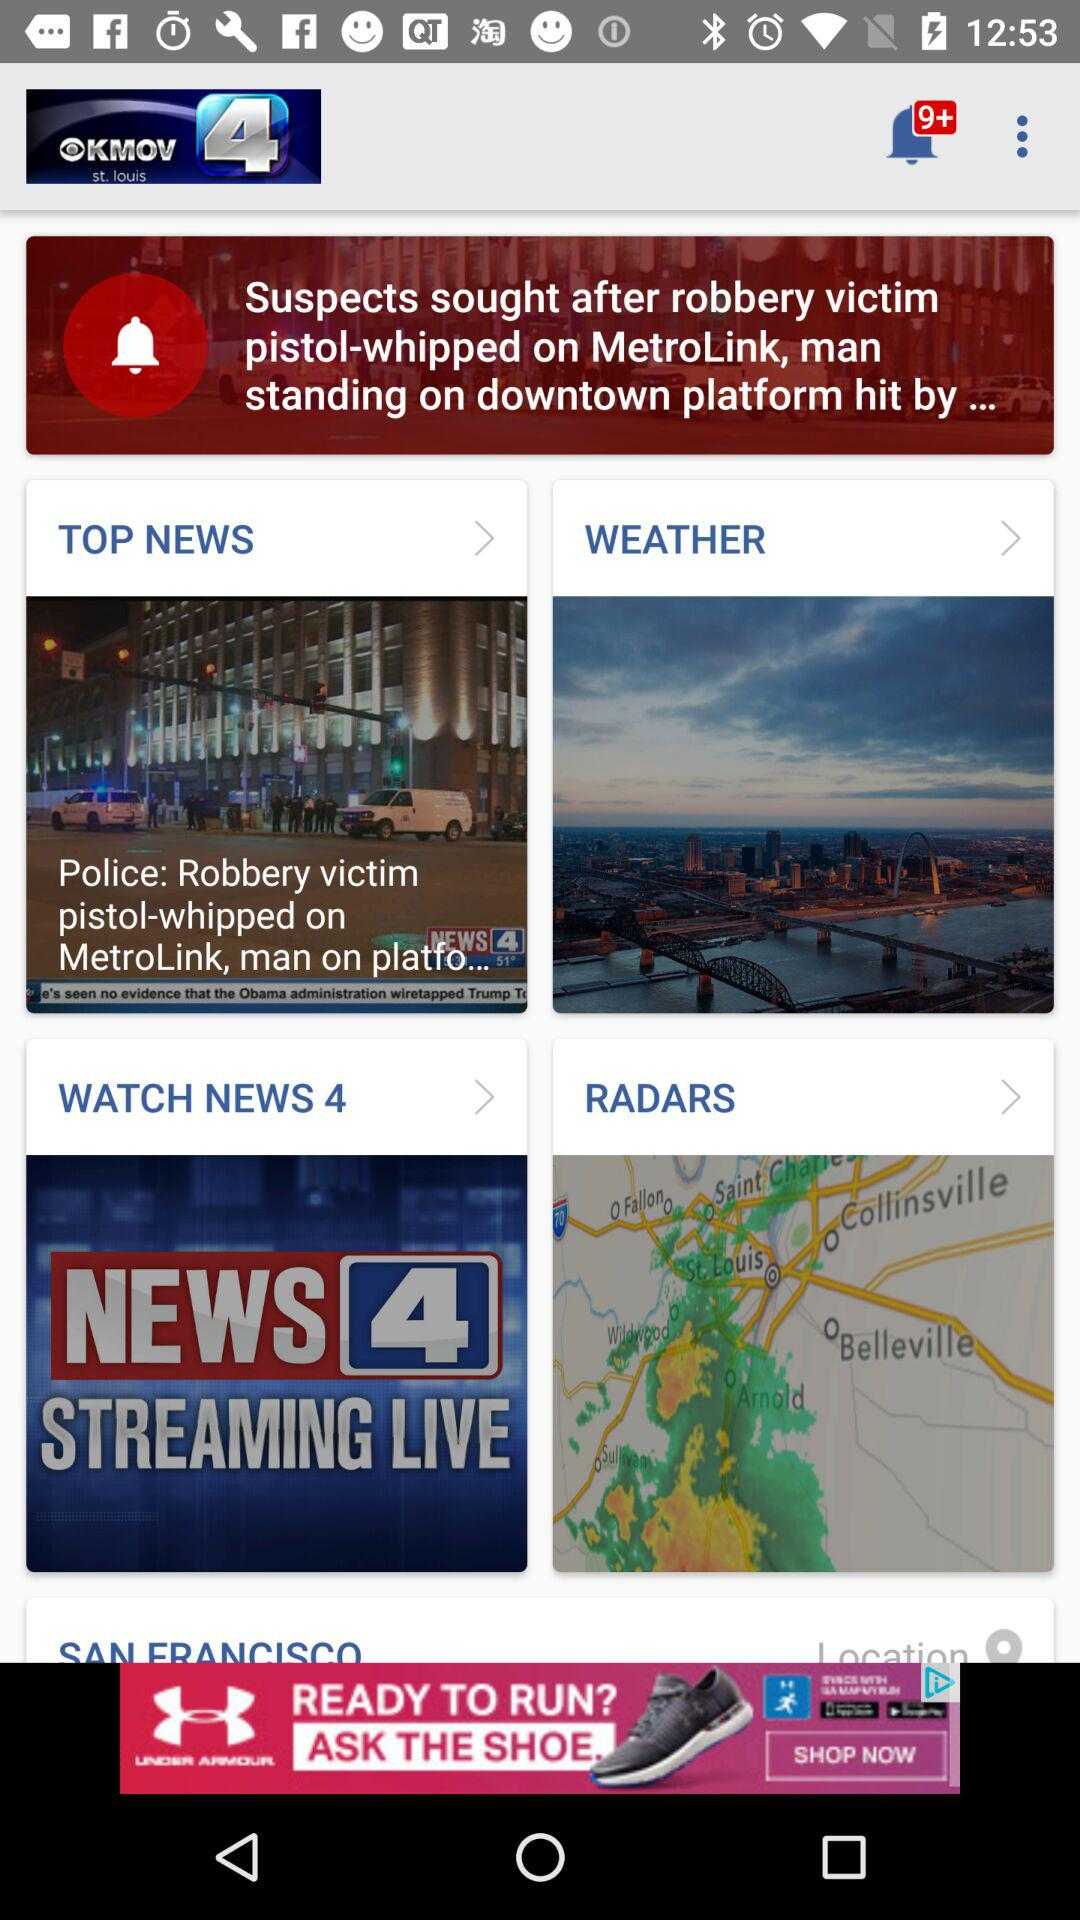What is the name of the news channel? The name of the news channel is "NEWS 4 STREAMING LIVE". 